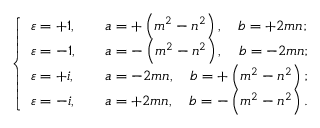<formula> <loc_0><loc_0><loc_500><loc_500>{ \left \{ \begin{array} { l l } { \varepsilon = + 1 , } & { \quad a = + \left ( m ^ { 2 } - n ^ { 2 } \right ) , \quad b = + 2 m n ; } \\ { \varepsilon = - 1 , } & { \quad a = - \left ( m ^ { 2 } - n ^ { 2 } \right ) , \quad b = - 2 m n ; } \\ { \varepsilon = + i , } & { \quad a = - 2 m n , \quad b = + \left ( m ^ { 2 } - n ^ { 2 } \right ) ; } \\ { \varepsilon = - i , } & { \quad a = + 2 m n , \quad b = - \left ( m ^ { 2 } - n ^ { 2 } \right ) . } \end{array} }</formula> 